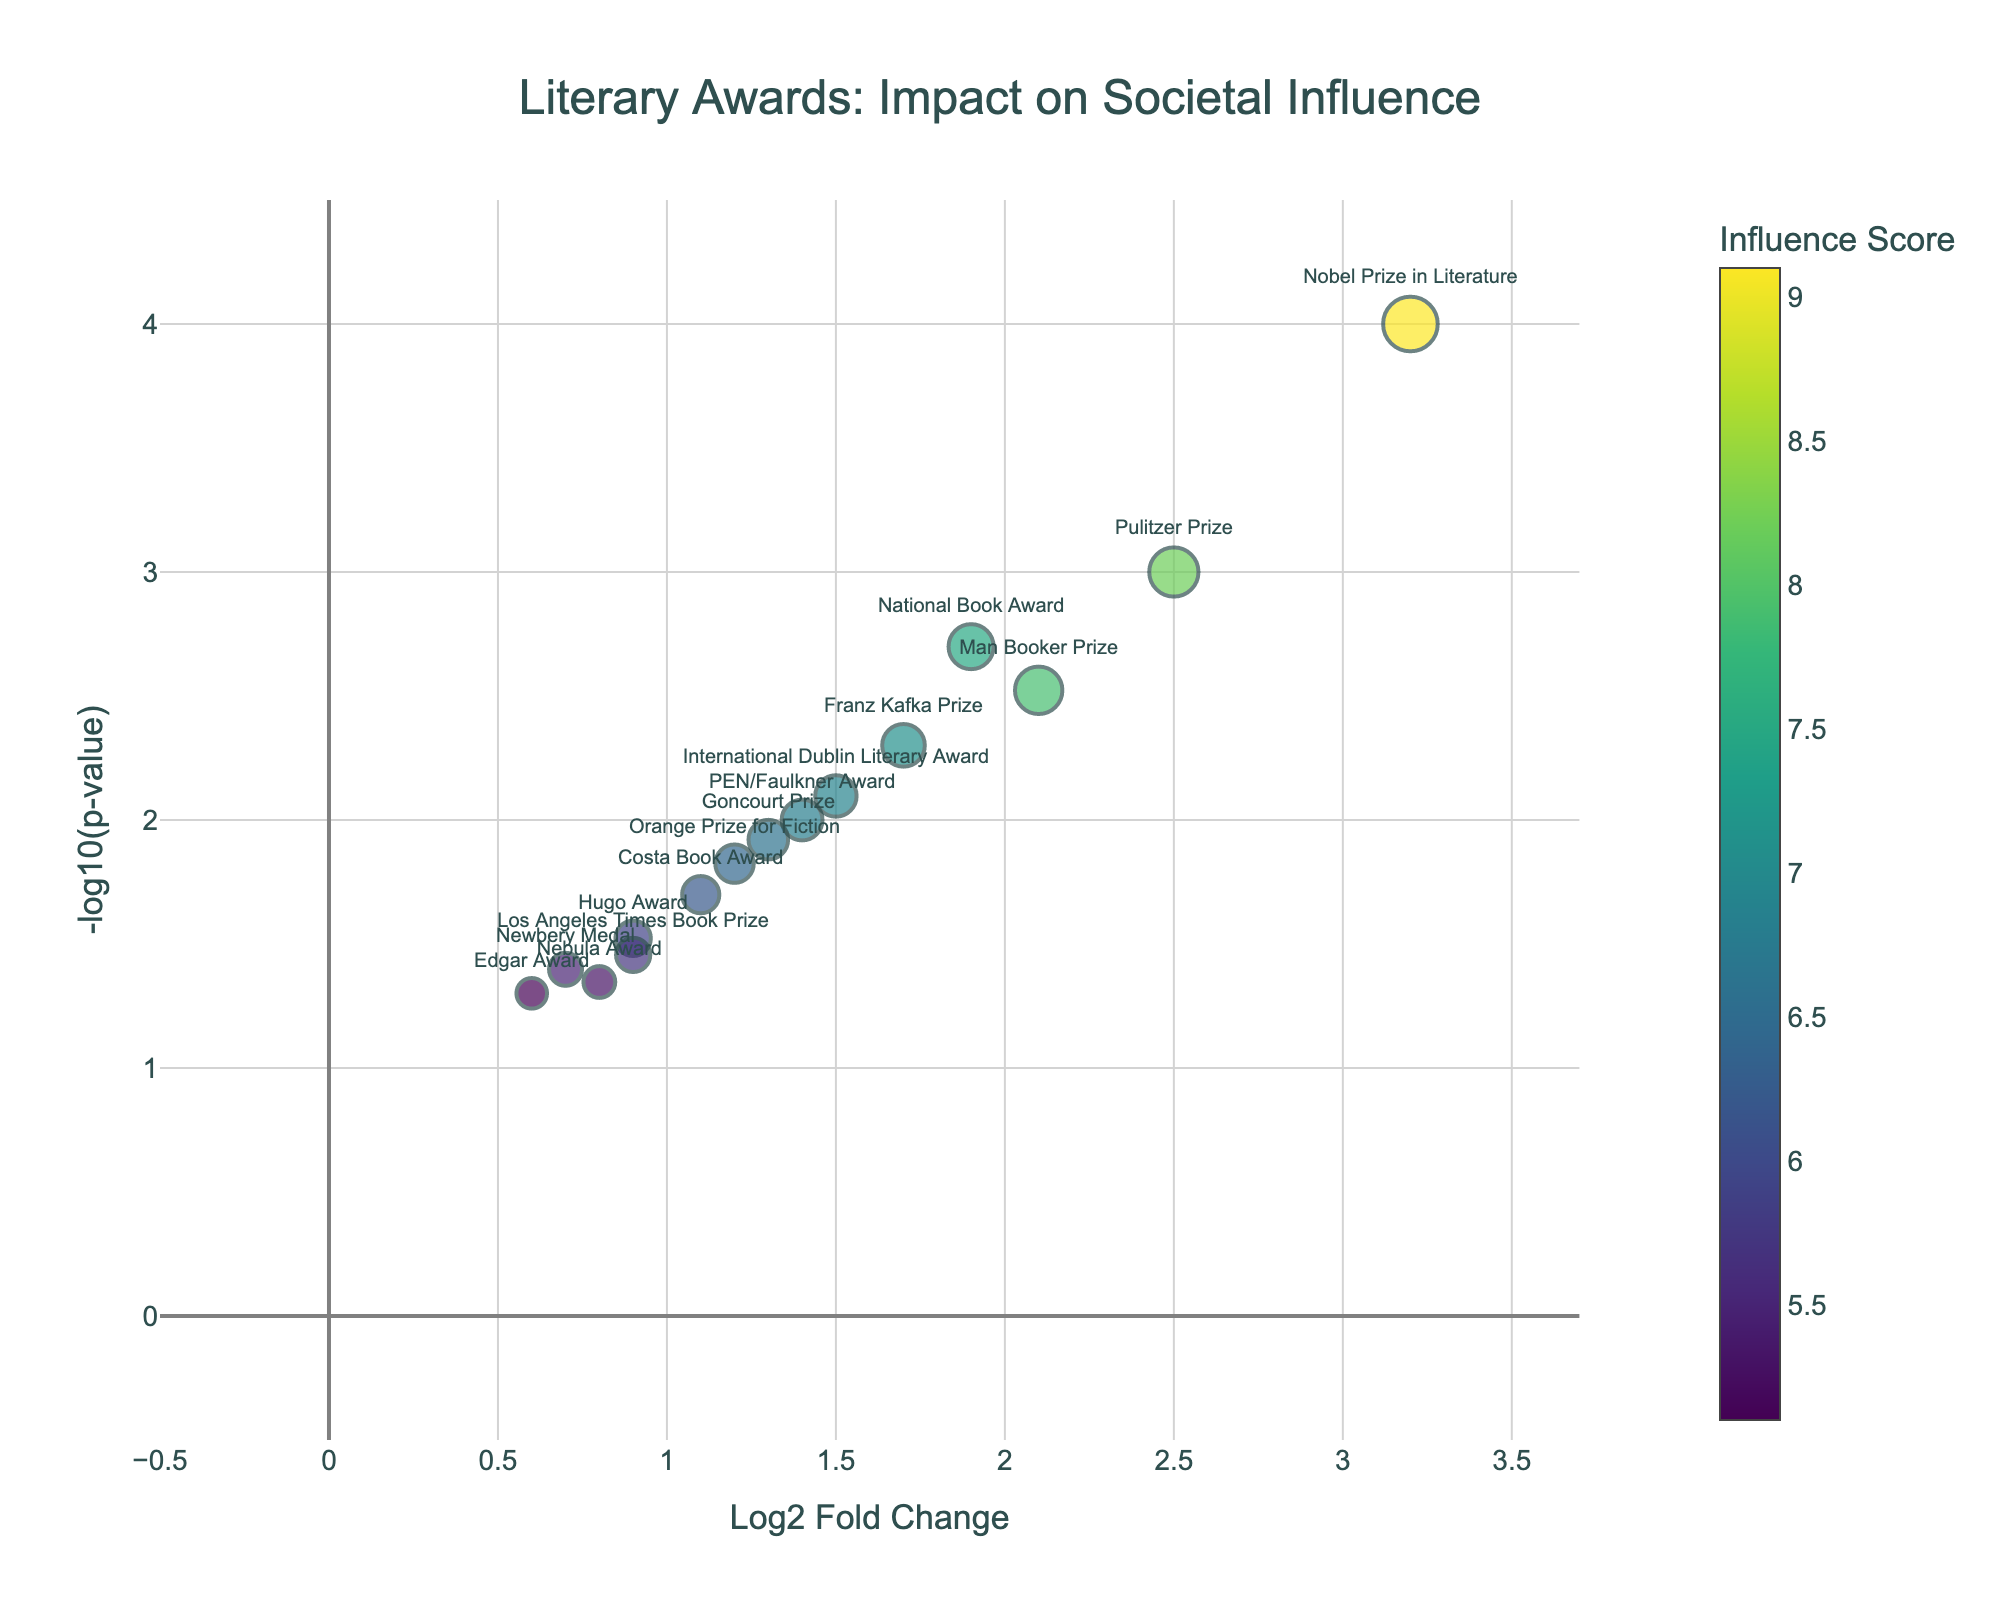what is the main title of the plot? The main title is typically displayed at the top center of the plot. In this case, it reads "Literary Awards: Impact on Societal Influence".
Answer: Literary Awards: Impact on Societal Influence what is represented on the x-axis? The x-axis label is "Log2 Fold Change", indicating that it represents the log2 fold change values for literary awards.
Answer: Log2 Fold Change what is represented on the y-axis? The y-axis label is "-log10(p-value)", signifying that it shows the negative log-transformed p-values for the dataset.
Answer: -log10(p-value) which award has the highest influence score? Look for the award associated with the largest bubble size and highest color intensity. The Nobel Prize in Literature has a value of 9.1, which is the highest influence score.
Answer: Nobel Prize in Literature how many awards have a -log10(p-value) greater than 2? Read the plot to count bubbles with y-values above 2. The awards are Pulitzer Prize, Man Booker Prize, National Book Award, Nobel Prize in Literature, PEN/Faulkner Award, Orange Prize for Fiction, Goncourt Prize, and International Dublin Literary Award.
Answer: 8 which awards are close to or exceeding the Log2 Fold Change value of 2? Check the plot for points at or right of the x-axis value of 2. The awards are the Pulitzer Prize and the Nobel Prize in Literature.
Answer: Pulitzer Prize, Nobel Prize in Literature which award is the farthest to the right on the x-axis? Find the point with the highest Log2 Fold Change. The Nobel Prize in Literature is the furthest to the right on the x-axis.
Answer: Nobel Prize in Literature which two awards have the closest -log10(p-value) values yet different Log2 Fold Change values? Compare bubbles that are closely aligned vertically (similar y-values) but horizontally separated (different x-values). The PEN/Faulkner Award and Goncourt Prize both have -log10(p-value) near 2 but distinct Log2 Fold Change values.
Answer: PEN/Faulkner Award, Goncourt Prize which awards have an influence score between 6 and 7? Identify awards represented by bubbles scaled between sizes corresponding to scores 6 and 7. These awards are Costa Book Award, Orange Prize for Fiction, Goncourt Prize, and International Dublin Literary Award.
Answer: Costa Book Award, Orange Prize for Fiction, Goncourt Prize, International Dublin Literary Award which award has the lowest influence score among the ones shown? Look for the smallest bubble size which represents the Newbery Medal with an influence score of 5.5.
Answer: Newbery Medal 